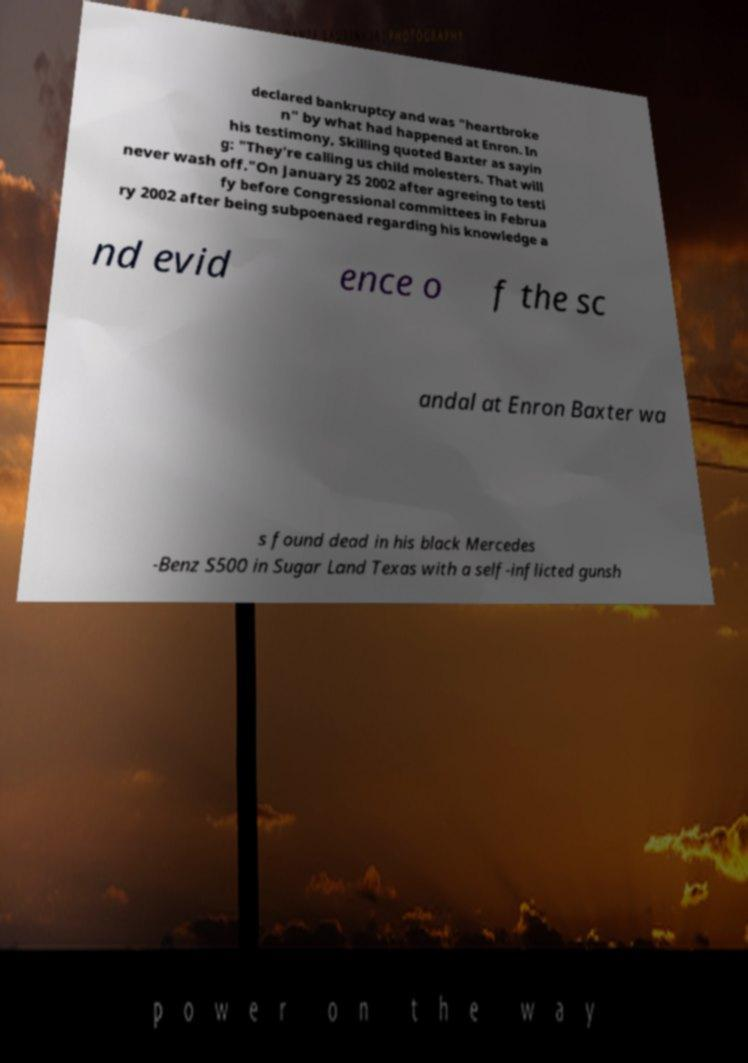I need the written content from this picture converted into text. Can you do that? declared bankruptcy and was "heartbroke n" by what had happened at Enron. In his testimony, Skilling quoted Baxter as sayin g: "They're calling us child molesters. That will never wash off."On January 25 2002 after agreeing to testi fy before Congressional committees in Februa ry 2002 after being subpoenaed regarding his knowledge a nd evid ence o f the sc andal at Enron Baxter wa s found dead in his black Mercedes -Benz S500 in Sugar Land Texas with a self-inflicted gunsh 